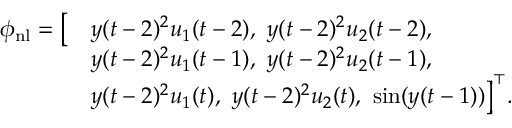<formula> <loc_0><loc_0><loc_500><loc_500>\begin{array} { r l } { \phi _ { n l } = \left [ } & { y ( t - 2 ) ^ { 2 } u _ { 1 } ( t - 2 ) , \ y ( t - 2 ) ^ { 2 } u _ { 2 } ( t - 2 ) , } \\ & { y ( t - 2 ) ^ { 2 } u _ { 1 } ( t - 1 ) , \ y ( t - 2 ) ^ { 2 } u _ { 2 } ( t - 1 ) , } \\ & { y ( t - 2 ) ^ { 2 } u _ { 1 } ( t ) , \ y ( t - 2 ) ^ { 2 } u _ { 2 } ( t ) , \ \sin ( y ( t - 1 ) ) \right ] ^ { \top } . } \end{array}</formula> 